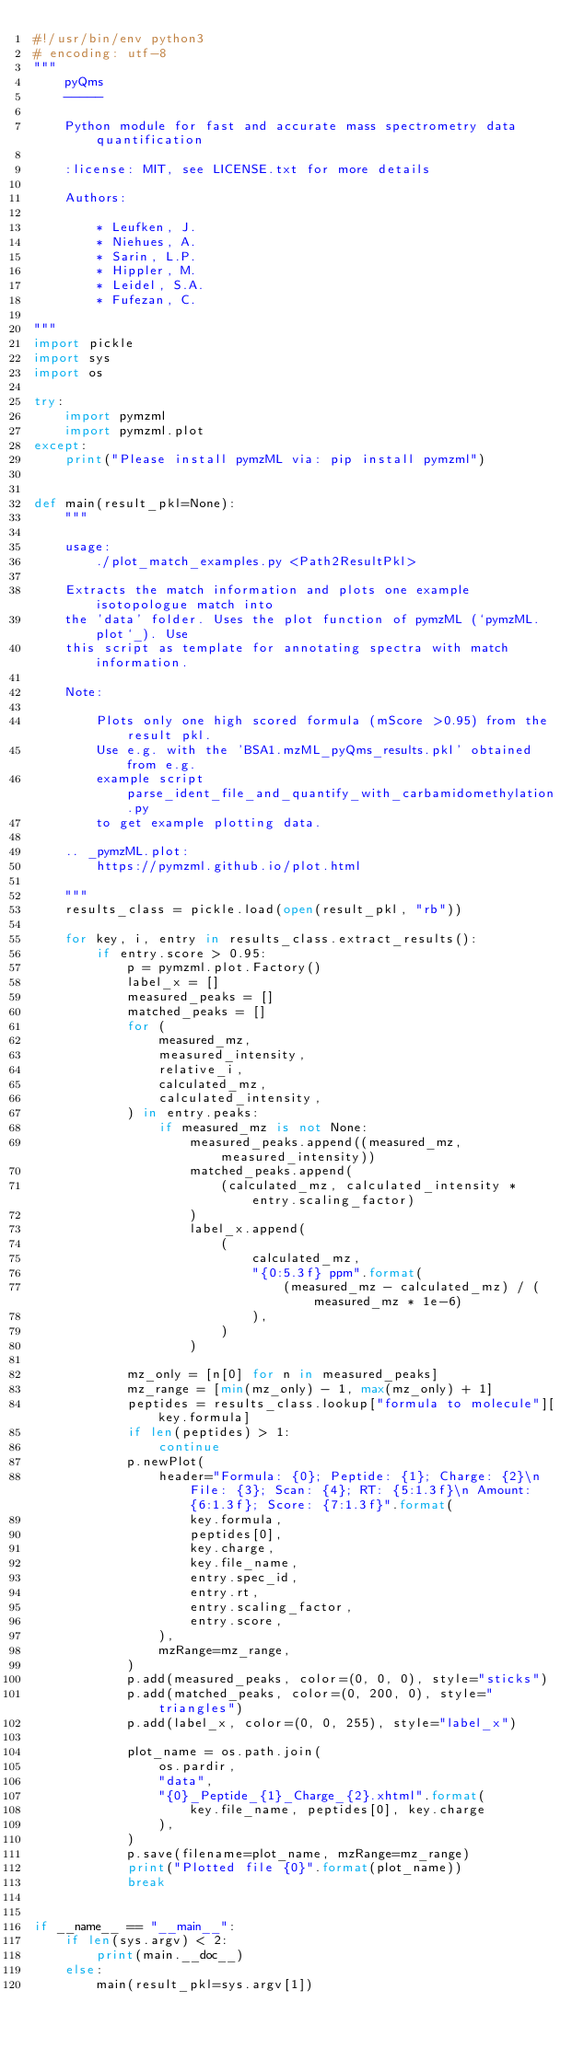Convert code to text. <code><loc_0><loc_0><loc_500><loc_500><_Python_>#!/usr/bin/env python3
# encoding: utf-8
"""
    pyQms
    -----

    Python module for fast and accurate mass spectrometry data quantification

    :license: MIT, see LICENSE.txt for more details

    Authors:

        * Leufken, J.
        * Niehues, A.
        * Sarin, L.P.
        * Hippler, M.
        * Leidel, S.A.
        * Fufezan, C.

"""
import pickle
import sys
import os

try:
    import pymzml
    import pymzml.plot
except:
    print("Please install pymzML via: pip install pymzml")


def main(result_pkl=None):
    """

    usage:
        ./plot_match_examples.py <Path2ResultPkl>

    Extracts the match information and plots one example isotopologue match into
    the 'data' folder. Uses the plot function of pymzML (`pymzML.plot`_). Use
    this script as template for annotating spectra with match information.

    Note:

        Plots only one high scored formula (mScore >0.95) from the result pkl.
        Use e.g. with the 'BSA1.mzML_pyQms_results.pkl' obtained from e.g.
        example script parse_ident_file_and_quantify_with_carbamidomethylation.py
        to get example plotting data.

    .. _pymzML.plot:
        https://pymzml.github.io/plot.html

    """
    results_class = pickle.load(open(result_pkl, "rb"))

    for key, i, entry in results_class.extract_results():
        if entry.score > 0.95:
            p = pymzml.plot.Factory()
            label_x = []
            measured_peaks = []
            matched_peaks = []
            for (
                measured_mz,
                measured_intensity,
                relative_i,
                calculated_mz,
                calculated_intensity,
            ) in entry.peaks:
                if measured_mz is not None:
                    measured_peaks.append((measured_mz, measured_intensity))
                    matched_peaks.append(
                        (calculated_mz, calculated_intensity * entry.scaling_factor)
                    )
                    label_x.append(
                        (
                            calculated_mz,
                            "{0:5.3f} ppm".format(
                                (measured_mz - calculated_mz) / (measured_mz * 1e-6)
                            ),
                        )
                    )

            mz_only = [n[0] for n in measured_peaks]
            mz_range = [min(mz_only) - 1, max(mz_only) + 1]
            peptides = results_class.lookup["formula to molecule"][key.formula]
            if len(peptides) > 1:
                continue
            p.newPlot(
                header="Formula: {0}; Peptide: {1}; Charge: {2}\n File: {3}; Scan: {4}; RT: {5:1.3f}\n Amount: {6:1.3f}; Score: {7:1.3f}".format(
                    key.formula,
                    peptides[0],
                    key.charge,
                    key.file_name,
                    entry.spec_id,
                    entry.rt,
                    entry.scaling_factor,
                    entry.score,
                ),
                mzRange=mz_range,
            )
            p.add(measured_peaks, color=(0, 0, 0), style="sticks")
            p.add(matched_peaks, color=(0, 200, 0), style="triangles")
            p.add(label_x, color=(0, 0, 255), style="label_x")

            plot_name = os.path.join(
                os.pardir,
                "data",
                "{0}_Peptide_{1}_Charge_{2}.xhtml".format(
                    key.file_name, peptides[0], key.charge
                ),
            )
            p.save(filename=plot_name, mzRange=mz_range)
            print("Plotted file {0}".format(plot_name))
            break


if __name__ == "__main__":
    if len(sys.argv) < 2:
        print(main.__doc__)
    else:
        main(result_pkl=sys.argv[1])
</code> 